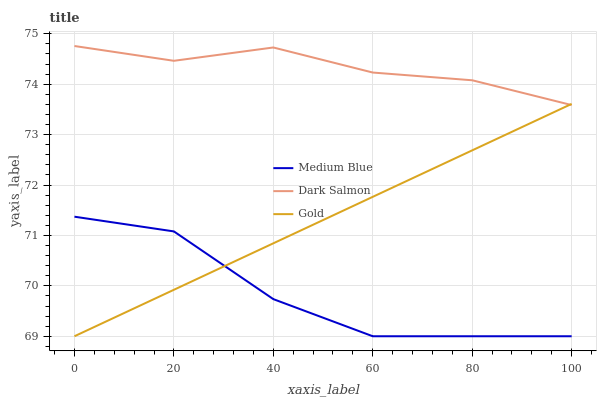Does Medium Blue have the minimum area under the curve?
Answer yes or no. Yes. Does Dark Salmon have the maximum area under the curve?
Answer yes or no. Yes. Does Gold have the minimum area under the curve?
Answer yes or no. No. Does Gold have the maximum area under the curve?
Answer yes or no. No. Is Gold the smoothest?
Answer yes or no. Yes. Is Medium Blue the roughest?
Answer yes or no. Yes. Is Dark Salmon the smoothest?
Answer yes or no. No. Is Dark Salmon the roughest?
Answer yes or no. No. Does Medium Blue have the lowest value?
Answer yes or no. Yes. Does Dark Salmon have the lowest value?
Answer yes or no. No. Does Dark Salmon have the highest value?
Answer yes or no. Yes. Does Gold have the highest value?
Answer yes or no. No. Is Medium Blue less than Dark Salmon?
Answer yes or no. Yes. Is Dark Salmon greater than Medium Blue?
Answer yes or no. Yes. Does Medium Blue intersect Gold?
Answer yes or no. Yes. Is Medium Blue less than Gold?
Answer yes or no. No. Is Medium Blue greater than Gold?
Answer yes or no. No. Does Medium Blue intersect Dark Salmon?
Answer yes or no. No. 